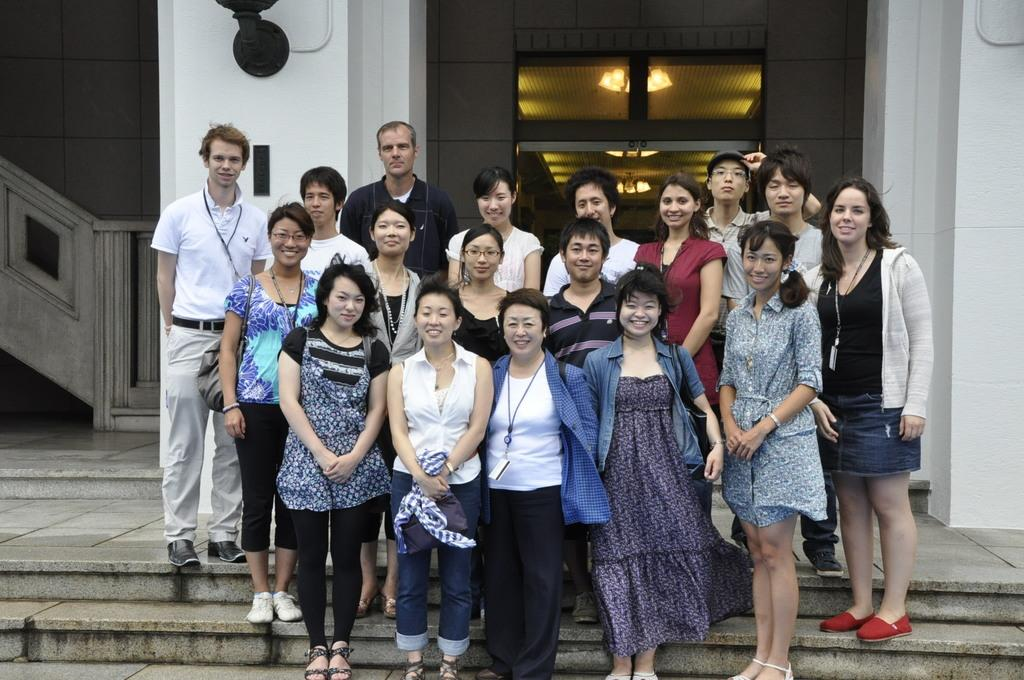What is the main subject of the image? The main subject of the image is a group of persons standing on the stairs in the center of the image. What can be seen in the background of the image? In the background of the image, there is a light, stairs, a door, and a building. How many elements can be identified in the background of the image? There are four elements in the background of the image: a light, stairs, a door, and a building. What type of attraction is the governor visiting in the image? There is no governor or attraction present in the image; it features a group of persons standing on stairs with a background that includes a light, stairs, a door, and a building. 